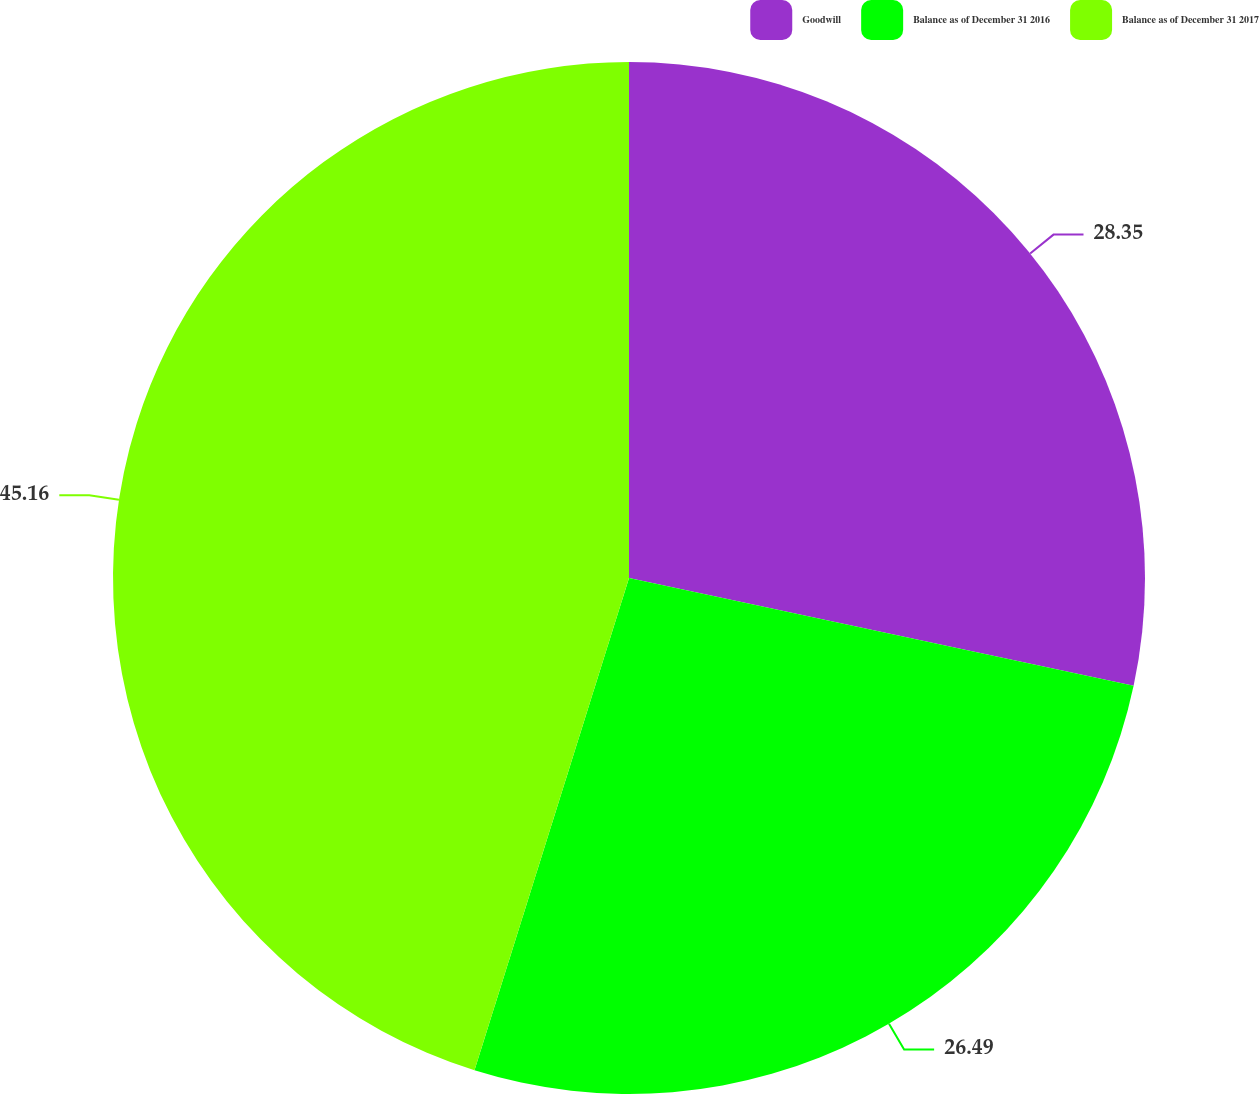<chart> <loc_0><loc_0><loc_500><loc_500><pie_chart><fcel>Goodwill<fcel>Balance as of December 31 2016<fcel>Balance as of December 31 2017<nl><fcel>28.35%<fcel>26.49%<fcel>45.16%<nl></chart> 